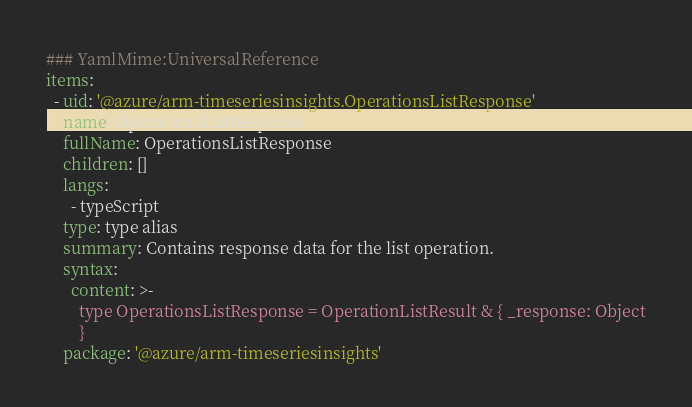<code> <loc_0><loc_0><loc_500><loc_500><_YAML_>### YamlMime:UniversalReference
items:
  - uid: '@azure/arm-timeseriesinsights.OperationsListResponse'
    name: OperationsListResponse
    fullName: OperationsListResponse
    children: []
    langs:
      - typeScript
    type: type alias
    summary: Contains response data for the list operation.
    syntax:
      content: >-
        type OperationsListResponse = OperationListResult & { _response: Object
        }
    package: '@azure/arm-timeseriesinsights'
</code> 